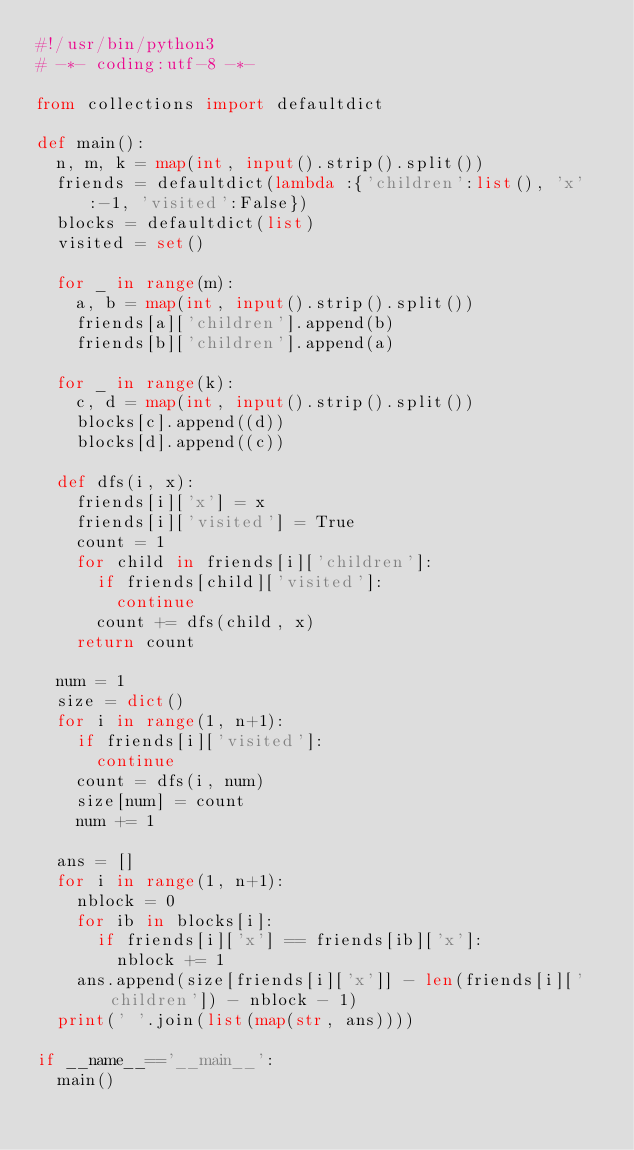Convert code to text. <code><loc_0><loc_0><loc_500><loc_500><_Python_>#!/usr/bin/python3
# -*- coding:utf-8 -*-

from collections import defaultdict

def main():
  n, m, k = map(int, input().strip().split())
  friends = defaultdict(lambda :{'children':list(), 'x':-1, 'visited':False})
  blocks = defaultdict(list)
  visited = set()
  
  for _ in range(m):
    a, b = map(int, input().strip().split())
    friends[a]['children'].append(b)
    friends[b]['children'].append(a)

  for _ in range(k):
    c, d = map(int, input().strip().split())
    blocks[c].append((d))
    blocks[d].append((c))
    
  def dfs(i, x):
    friends[i]['x'] = x
    friends[i]['visited'] = True
    count = 1
    for child in friends[i]['children']:
      if friends[child]['visited']:
        continue
      count += dfs(child, x)
    return count
  
  num = 1
  size = dict()
  for i in range(1, n+1):
    if friends[i]['visited']:
      continue
    count = dfs(i, num)
    size[num] = count
    num += 1
    
  ans = []
  for i in range(1, n+1):
    nblock = 0
    for ib in blocks[i]:
      if friends[i]['x'] == friends[ib]['x']:
        nblock += 1
    ans.append(size[friends[i]['x']] - len(friends[i]['children']) - nblock - 1)
  print(' '.join(list(map(str, ans))))
  
if __name__=='__main__':
  main()

</code> 